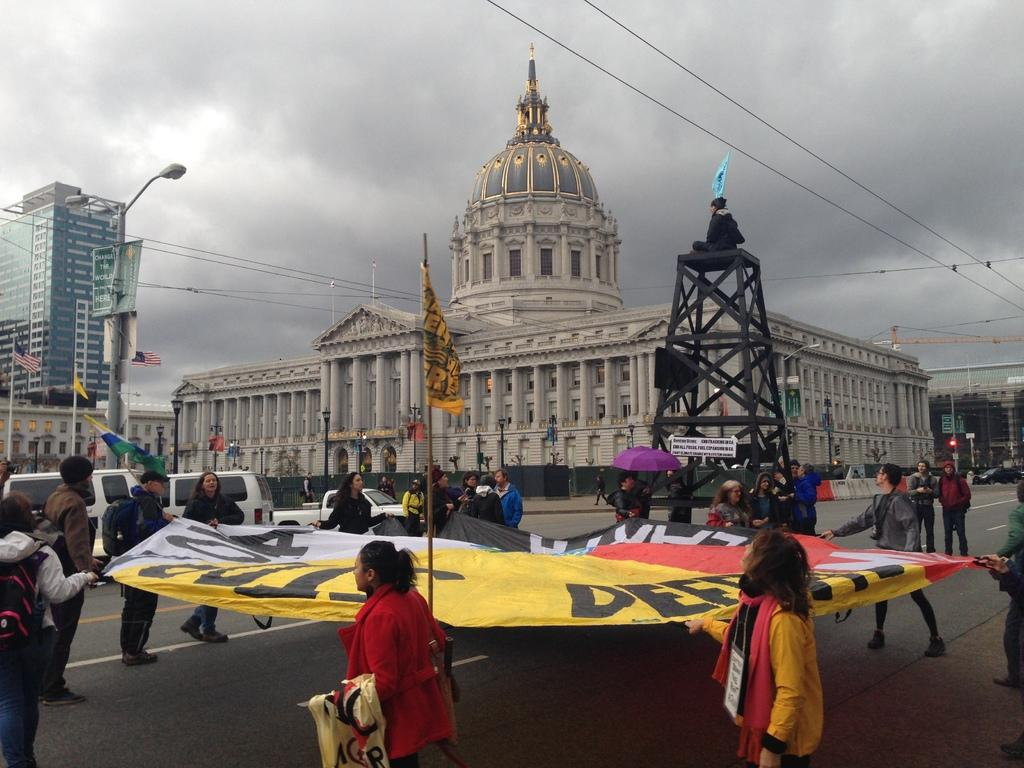How many people are in the image? There is a group of people in the image, but the exact number is not specified. What are the people holding in the image? The people are holding a banner in the image. What else can be seen in the image besides the people and banner? There are flags, light poles, buildings, and the sky in the image. What is the color of the sky in the image? The sky is white and gray in color. What type of advertisement can be seen on the chairs in the image? There are no chairs present in the image, so there is no advertisement on chairs to be seen. 